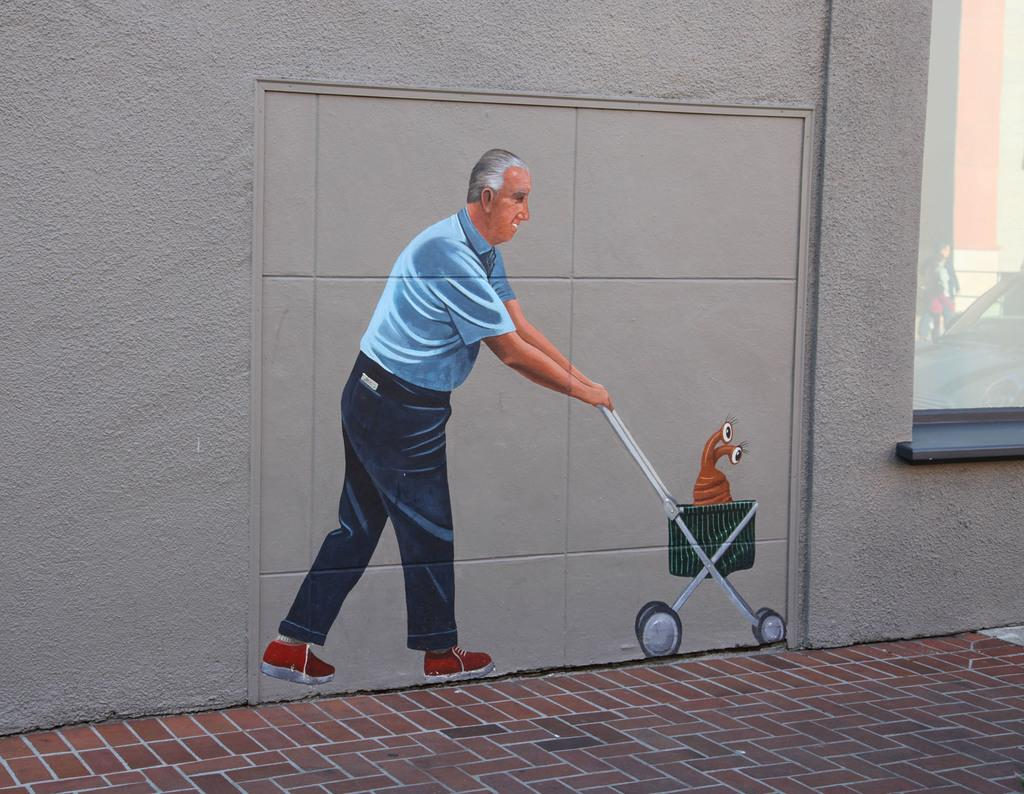What is depicted in the art in the image? There is an art of a person holding a trolley in the image. What can be seen on the trolley in the image? There is an insect on the wall of a building in the trolley. What type of structure is visible in the image? There is a building in the image. What is the ground surface like in front of the building? There is a path in front of the building. Where is the cactus located in the image? There is no cactus present in the image. What type of jar is visible on the path in front of the building? There is no jar present on the path in front of the building. 